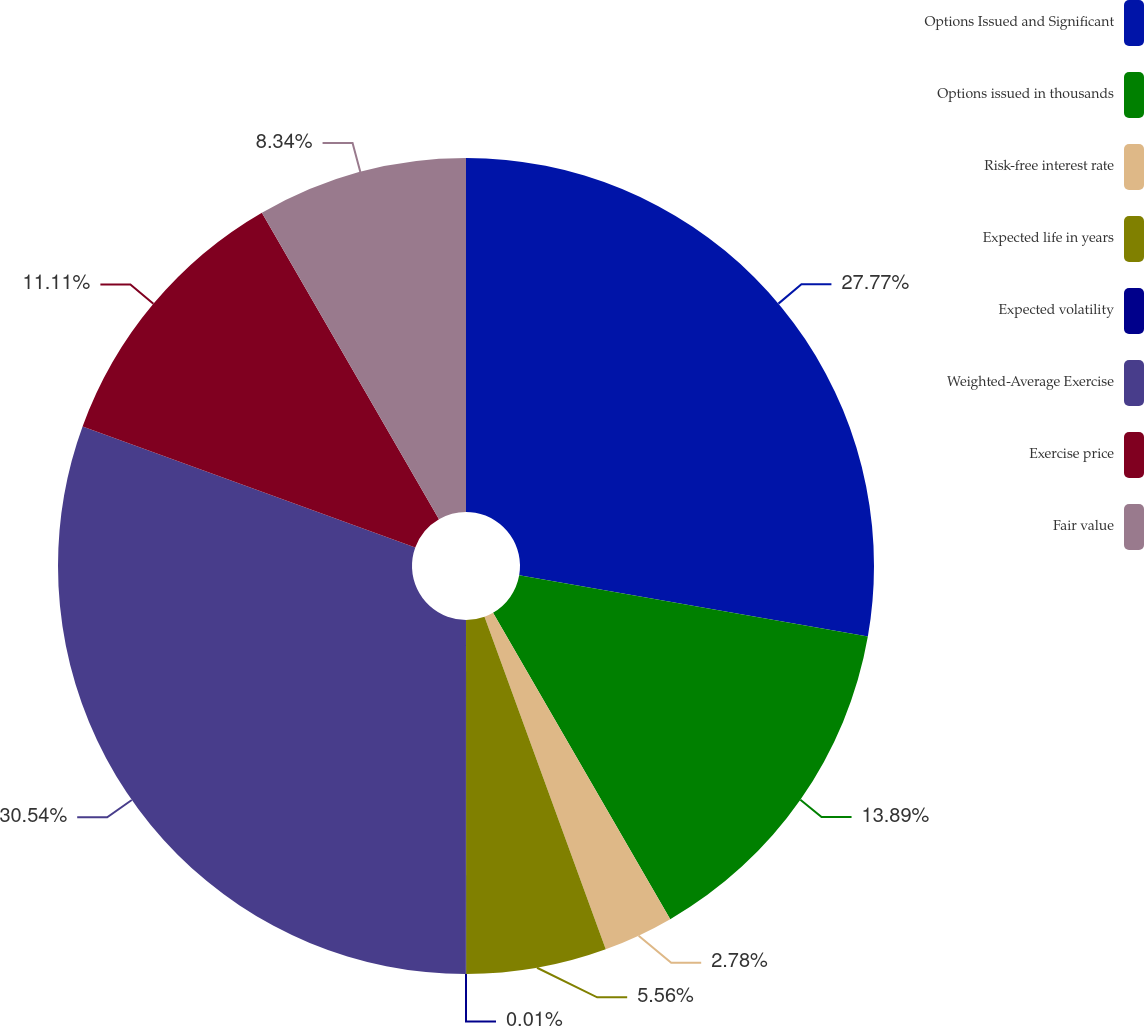Convert chart to OTSL. <chart><loc_0><loc_0><loc_500><loc_500><pie_chart><fcel>Options Issued and Significant<fcel>Options issued in thousands<fcel>Risk-free interest rate<fcel>Expected life in years<fcel>Expected volatility<fcel>Weighted-Average Exercise<fcel>Exercise price<fcel>Fair value<nl><fcel>27.77%<fcel>13.89%<fcel>2.78%<fcel>5.56%<fcel>0.01%<fcel>30.55%<fcel>11.11%<fcel>8.34%<nl></chart> 